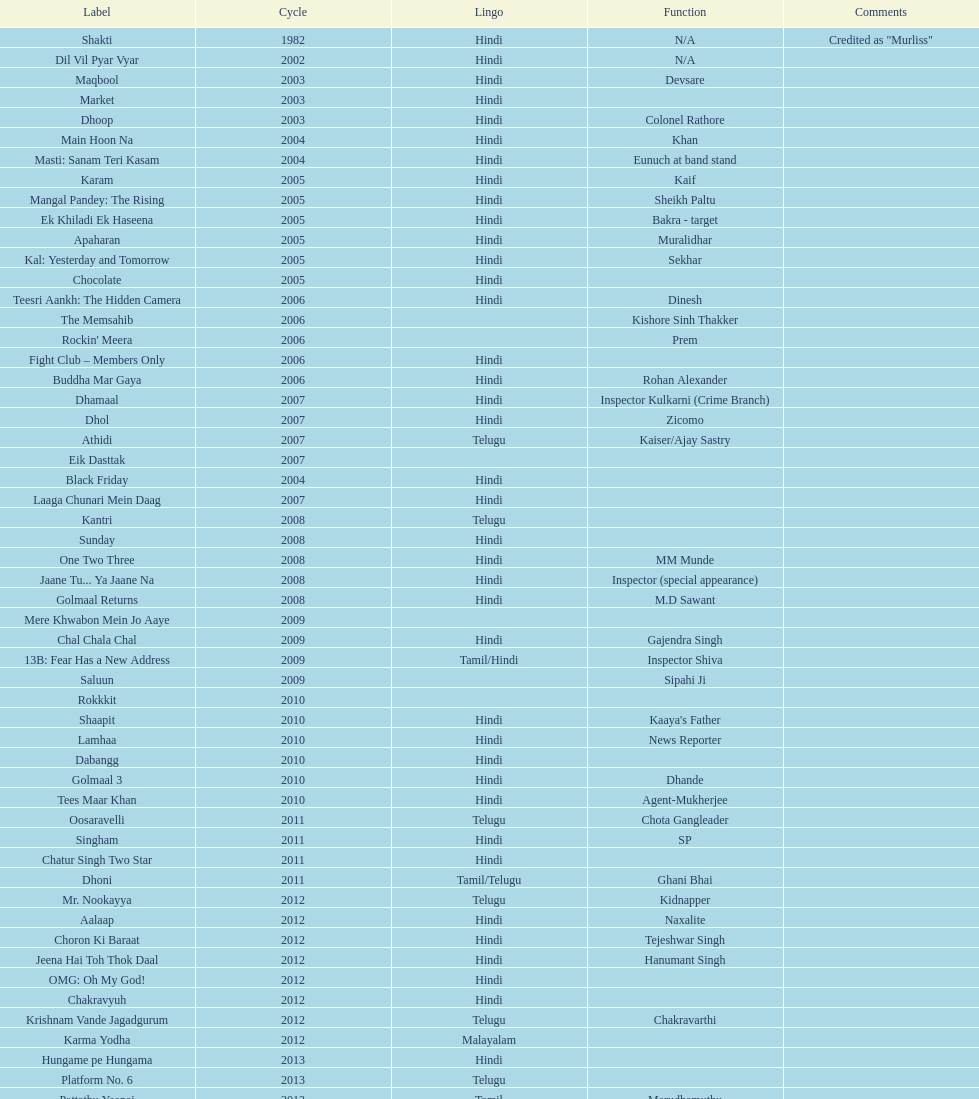What is the first language after hindi Telugu. 